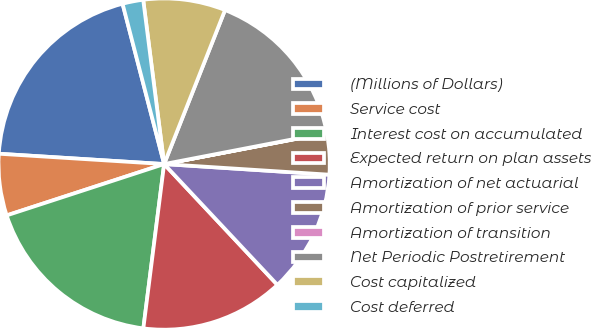<chart> <loc_0><loc_0><loc_500><loc_500><pie_chart><fcel>(Millions of Dollars)<fcel>Service cost<fcel>Interest cost on accumulated<fcel>Expected return on plan assets<fcel>Amortization of net actuarial<fcel>Amortization of prior service<fcel>Amortization of transition<fcel>Net Periodic Postretirement<fcel>Cost capitalized<fcel>Cost deferred<nl><fcel>19.97%<fcel>6.01%<fcel>17.98%<fcel>13.99%<fcel>11.99%<fcel>4.02%<fcel>0.03%<fcel>15.98%<fcel>8.01%<fcel>2.02%<nl></chart> 